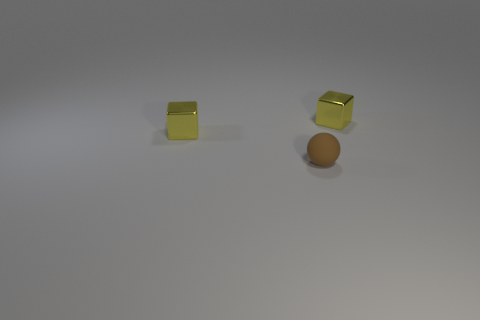Are there any other things that have the same material as the ball?
Offer a terse response. No. What number of objects are either shiny things or tiny yellow objects right of the matte thing?
Your answer should be very brief. 2. There is a small brown thing; how many tiny spheres are behind it?
Offer a very short reply. 0. How many matte things are tiny brown objects or small cubes?
Keep it short and to the point. 1. What shape is the metal thing that is on the right side of the brown matte sphere?
Offer a very short reply. Cube. Is there a tiny yellow block on the left side of the small yellow metallic block to the right of the sphere?
Give a very brief answer. Yes. Are there any metal blocks of the same size as the brown ball?
Provide a short and direct response. Yes. How big is the brown ball?
Offer a terse response. Small. How many small balls have the same color as the rubber thing?
Offer a terse response. 0. How many large green rubber spheres are there?
Provide a succinct answer. 0. 